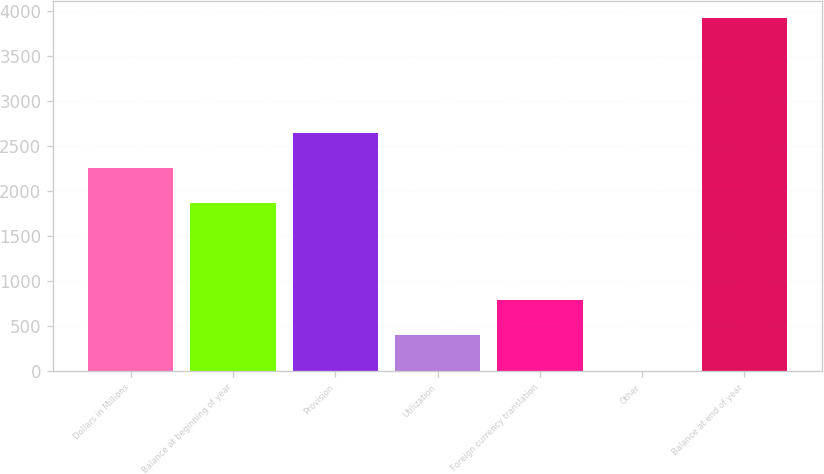<chart> <loc_0><loc_0><loc_500><loc_500><bar_chart><fcel>Dollars in Millions<fcel>Balance at beginning of year<fcel>Provision<fcel>Utilization<fcel>Foreign currency translation<fcel>Other<fcel>Balance at end of year<nl><fcel>2254.6<fcel>1863<fcel>2646.2<fcel>395.6<fcel>787.2<fcel>4<fcel>3920<nl></chart> 